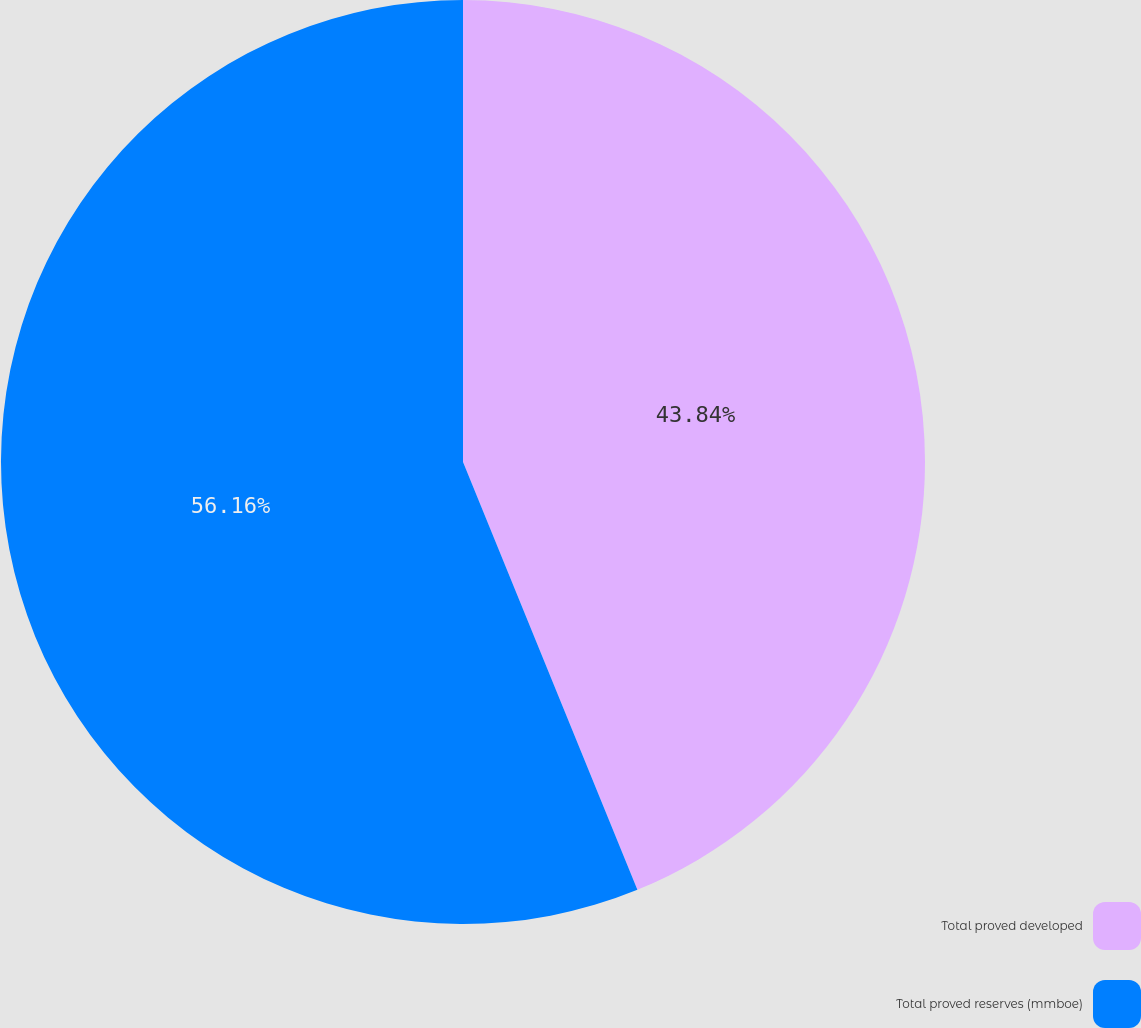<chart> <loc_0><loc_0><loc_500><loc_500><pie_chart><fcel>Total proved developed<fcel>Total proved reserves (mmboe)<nl><fcel>43.84%<fcel>56.16%<nl></chart> 